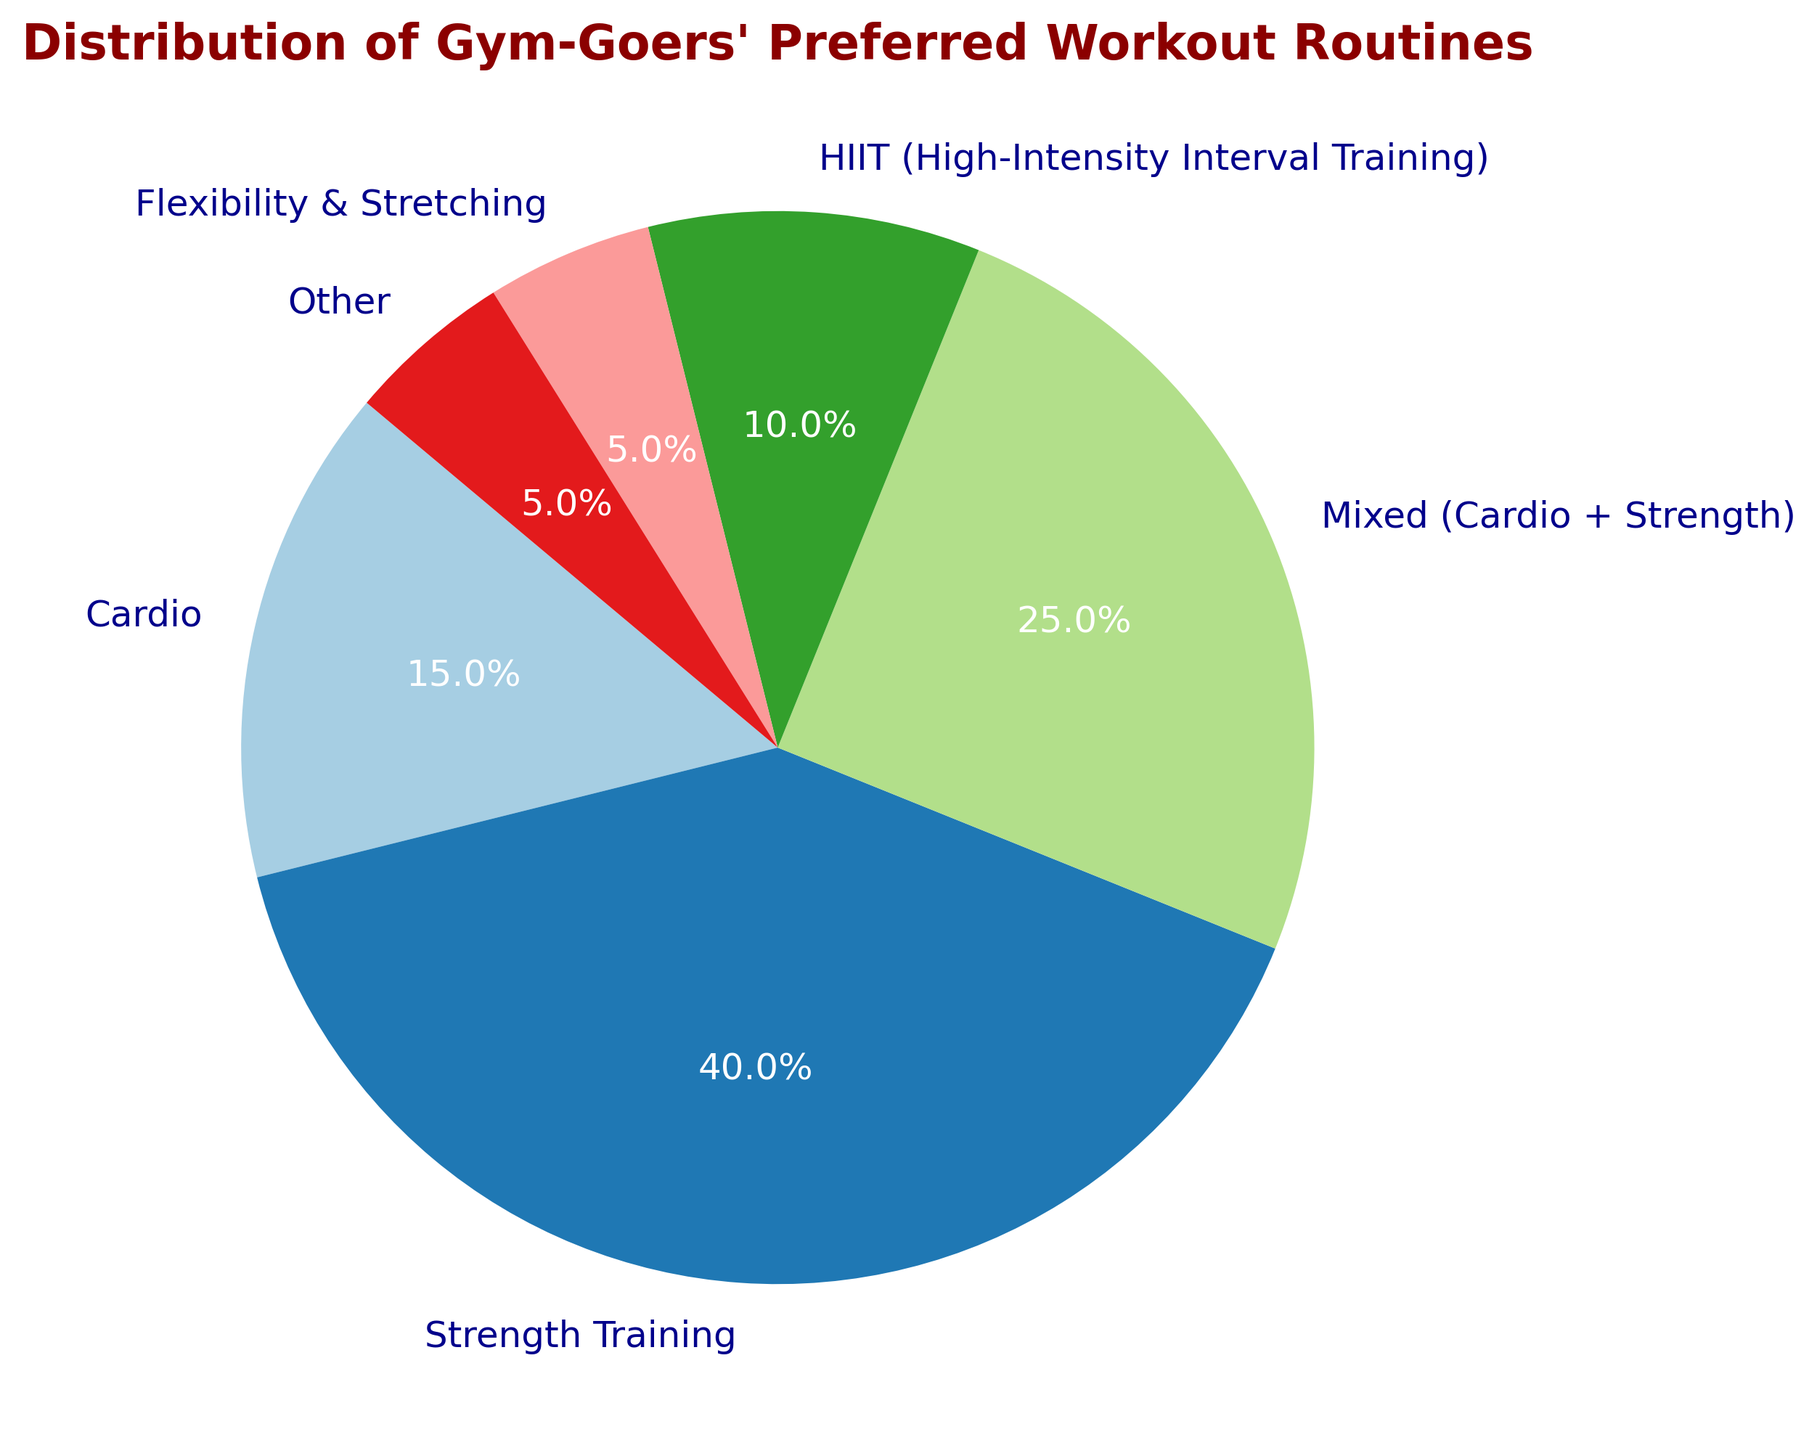Which workout routine is preferred by the largest percentage of gym-goers? The figure shows that Strength Training has the largest slice of the pie chart.
Answer: Strength Training Which two workout routines together account for more than half of the gym-goers' preferences? Adding the percentages of Strength Training (40%) and Mixed (Cardio + Strength) (25%) equals 65%, which is more than half.
Answer: Strength Training and Mixed (Cardio + Strength) How much larger is the percentage of gym-goers who prefer Strength Training compared to those who prefer HIIT? Strength Training is 40% and HIIT is 10%. The difference is calculated as 40% - 10%.
Answer: 30% What is the percentage difference between cardio and flexibility & stretching routines? Cardio has 15% and Flexibility & Stretching has 5%. The difference is calculated as 15% - 5%.
Answer: 10% What is the combined percentage of gym-goers who prefer Flexibility & Stretching and other routines? Flexibility & Stretching is 5% and Other is 5%. Combined, it is 5% + 5%.
Answer: 10% Which workout routine has the smallest slice in the pie chart? Both Flexibility & Stretching and Other have the smallest slices, each at 5%.
Answer: Flexibility & Stretching and Other How does the percentage of gym-goers who prefer HIIT compare to those who prefer a mixed routine? HIIT is 10% while Mixed (Cardio + Strength) is 25%. HIIT is smaller.
Answer: Less By how many percentage points does Strength Training preference exceed Mixed (Cardio + Strength) preference? Strength Training is preferred by 40% and Mixed (Cardio + Strength) by 25%. The difference is 40% - 25%.
Answer: 15% What percentage of gym-goers prefer routines other than Strength Training? Subtracting Strength Training (40%) from 100% gives 100% - 40%.
Answer: 60% What is the total percentage of gym-goers who prefer cardio, strength training, and HIIT combined? Adding Cardio (15%), Strength Training (40%), and HIIT (10%) gives 15% + 40% + 10%.
Answer: 65% 